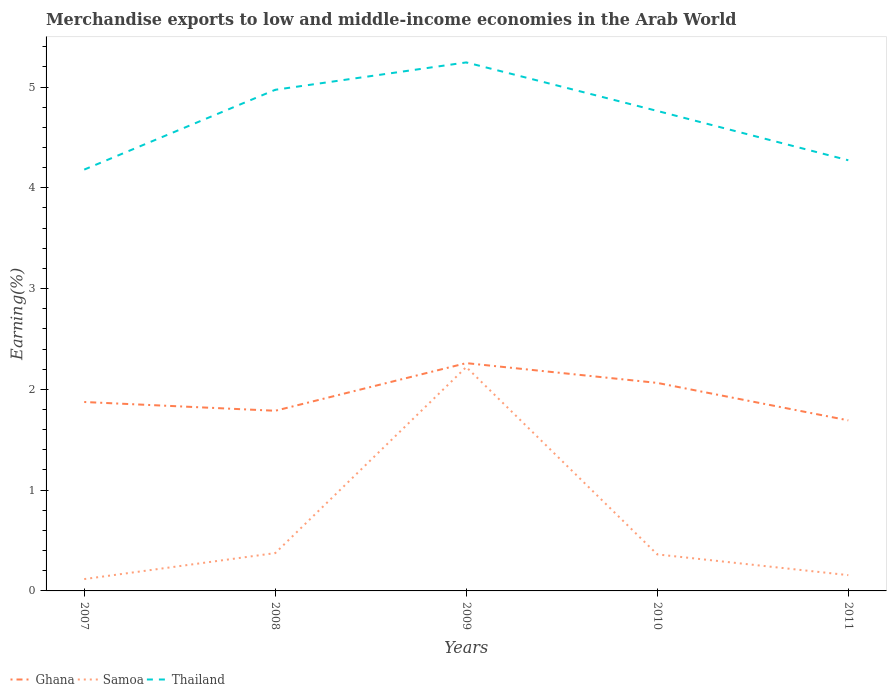Across all years, what is the maximum percentage of amount earned from merchandise exports in Thailand?
Keep it short and to the point. 4.18. What is the total percentage of amount earned from merchandise exports in Samoa in the graph?
Offer a terse response. 0.21. What is the difference between the highest and the second highest percentage of amount earned from merchandise exports in Ghana?
Your response must be concise. 0.57. What is the difference between the highest and the lowest percentage of amount earned from merchandise exports in Ghana?
Your answer should be compact. 2. How many years are there in the graph?
Your response must be concise. 5. What is the difference between two consecutive major ticks on the Y-axis?
Ensure brevity in your answer.  1. Are the values on the major ticks of Y-axis written in scientific E-notation?
Make the answer very short. No. Does the graph contain grids?
Provide a short and direct response. No. How are the legend labels stacked?
Make the answer very short. Horizontal. What is the title of the graph?
Your response must be concise. Merchandise exports to low and middle-income economies in the Arab World. What is the label or title of the Y-axis?
Your answer should be compact. Earning(%). What is the Earning(%) of Ghana in 2007?
Give a very brief answer. 1.87. What is the Earning(%) of Samoa in 2007?
Your answer should be compact. 0.12. What is the Earning(%) in Thailand in 2007?
Keep it short and to the point. 4.18. What is the Earning(%) in Ghana in 2008?
Provide a short and direct response. 1.79. What is the Earning(%) of Samoa in 2008?
Ensure brevity in your answer.  0.38. What is the Earning(%) of Thailand in 2008?
Give a very brief answer. 4.97. What is the Earning(%) in Ghana in 2009?
Your answer should be very brief. 2.26. What is the Earning(%) in Samoa in 2009?
Your answer should be very brief. 2.22. What is the Earning(%) in Thailand in 2009?
Your response must be concise. 5.24. What is the Earning(%) in Ghana in 2010?
Make the answer very short. 2.06. What is the Earning(%) in Samoa in 2010?
Offer a terse response. 0.36. What is the Earning(%) of Thailand in 2010?
Ensure brevity in your answer.  4.76. What is the Earning(%) in Ghana in 2011?
Provide a short and direct response. 1.69. What is the Earning(%) in Samoa in 2011?
Offer a terse response. 0.16. What is the Earning(%) of Thailand in 2011?
Your answer should be very brief. 4.27. Across all years, what is the maximum Earning(%) of Ghana?
Ensure brevity in your answer.  2.26. Across all years, what is the maximum Earning(%) in Samoa?
Offer a very short reply. 2.22. Across all years, what is the maximum Earning(%) of Thailand?
Make the answer very short. 5.24. Across all years, what is the minimum Earning(%) in Ghana?
Provide a short and direct response. 1.69. Across all years, what is the minimum Earning(%) of Samoa?
Ensure brevity in your answer.  0.12. Across all years, what is the minimum Earning(%) in Thailand?
Your response must be concise. 4.18. What is the total Earning(%) of Ghana in the graph?
Your response must be concise. 9.68. What is the total Earning(%) of Samoa in the graph?
Provide a succinct answer. 3.23. What is the total Earning(%) in Thailand in the graph?
Ensure brevity in your answer.  23.43. What is the difference between the Earning(%) of Ghana in 2007 and that in 2008?
Offer a very short reply. 0.09. What is the difference between the Earning(%) of Samoa in 2007 and that in 2008?
Give a very brief answer. -0.26. What is the difference between the Earning(%) of Thailand in 2007 and that in 2008?
Your answer should be compact. -0.79. What is the difference between the Earning(%) of Ghana in 2007 and that in 2009?
Keep it short and to the point. -0.39. What is the difference between the Earning(%) in Samoa in 2007 and that in 2009?
Offer a very short reply. -2.1. What is the difference between the Earning(%) of Thailand in 2007 and that in 2009?
Provide a short and direct response. -1.06. What is the difference between the Earning(%) of Ghana in 2007 and that in 2010?
Ensure brevity in your answer.  -0.19. What is the difference between the Earning(%) in Samoa in 2007 and that in 2010?
Your answer should be compact. -0.24. What is the difference between the Earning(%) of Thailand in 2007 and that in 2010?
Your answer should be very brief. -0.58. What is the difference between the Earning(%) in Ghana in 2007 and that in 2011?
Keep it short and to the point. 0.18. What is the difference between the Earning(%) in Samoa in 2007 and that in 2011?
Give a very brief answer. -0.04. What is the difference between the Earning(%) of Thailand in 2007 and that in 2011?
Offer a terse response. -0.09. What is the difference between the Earning(%) in Ghana in 2008 and that in 2009?
Your answer should be very brief. -0.47. What is the difference between the Earning(%) in Samoa in 2008 and that in 2009?
Provide a short and direct response. -1.85. What is the difference between the Earning(%) in Thailand in 2008 and that in 2009?
Offer a very short reply. -0.27. What is the difference between the Earning(%) of Ghana in 2008 and that in 2010?
Your response must be concise. -0.28. What is the difference between the Earning(%) in Samoa in 2008 and that in 2010?
Offer a terse response. 0.01. What is the difference between the Earning(%) of Thailand in 2008 and that in 2010?
Your response must be concise. 0.21. What is the difference between the Earning(%) of Ghana in 2008 and that in 2011?
Give a very brief answer. 0.1. What is the difference between the Earning(%) of Samoa in 2008 and that in 2011?
Your response must be concise. 0.22. What is the difference between the Earning(%) of Thailand in 2008 and that in 2011?
Offer a very short reply. 0.7. What is the difference between the Earning(%) in Ghana in 2009 and that in 2010?
Ensure brevity in your answer.  0.2. What is the difference between the Earning(%) of Samoa in 2009 and that in 2010?
Give a very brief answer. 1.86. What is the difference between the Earning(%) of Thailand in 2009 and that in 2010?
Offer a very short reply. 0.48. What is the difference between the Earning(%) of Ghana in 2009 and that in 2011?
Give a very brief answer. 0.57. What is the difference between the Earning(%) of Samoa in 2009 and that in 2011?
Your answer should be compact. 2.06. What is the difference between the Earning(%) of Ghana in 2010 and that in 2011?
Make the answer very short. 0.37. What is the difference between the Earning(%) of Samoa in 2010 and that in 2011?
Keep it short and to the point. 0.21. What is the difference between the Earning(%) in Thailand in 2010 and that in 2011?
Offer a terse response. 0.49. What is the difference between the Earning(%) of Ghana in 2007 and the Earning(%) of Samoa in 2008?
Offer a very short reply. 1.5. What is the difference between the Earning(%) of Ghana in 2007 and the Earning(%) of Thailand in 2008?
Your answer should be very brief. -3.1. What is the difference between the Earning(%) in Samoa in 2007 and the Earning(%) in Thailand in 2008?
Make the answer very short. -4.86. What is the difference between the Earning(%) in Ghana in 2007 and the Earning(%) in Samoa in 2009?
Offer a terse response. -0.35. What is the difference between the Earning(%) of Ghana in 2007 and the Earning(%) of Thailand in 2009?
Offer a terse response. -3.37. What is the difference between the Earning(%) of Samoa in 2007 and the Earning(%) of Thailand in 2009?
Offer a terse response. -5.13. What is the difference between the Earning(%) in Ghana in 2007 and the Earning(%) in Samoa in 2010?
Your response must be concise. 1.51. What is the difference between the Earning(%) in Ghana in 2007 and the Earning(%) in Thailand in 2010?
Your response must be concise. -2.89. What is the difference between the Earning(%) of Samoa in 2007 and the Earning(%) of Thailand in 2010?
Your answer should be compact. -4.65. What is the difference between the Earning(%) in Ghana in 2007 and the Earning(%) in Samoa in 2011?
Provide a short and direct response. 1.72. What is the difference between the Earning(%) in Ghana in 2007 and the Earning(%) in Thailand in 2011?
Ensure brevity in your answer.  -2.4. What is the difference between the Earning(%) in Samoa in 2007 and the Earning(%) in Thailand in 2011?
Keep it short and to the point. -4.16. What is the difference between the Earning(%) of Ghana in 2008 and the Earning(%) of Samoa in 2009?
Provide a short and direct response. -0.43. What is the difference between the Earning(%) of Ghana in 2008 and the Earning(%) of Thailand in 2009?
Your response must be concise. -3.46. What is the difference between the Earning(%) of Samoa in 2008 and the Earning(%) of Thailand in 2009?
Ensure brevity in your answer.  -4.87. What is the difference between the Earning(%) of Ghana in 2008 and the Earning(%) of Samoa in 2010?
Give a very brief answer. 1.43. What is the difference between the Earning(%) in Ghana in 2008 and the Earning(%) in Thailand in 2010?
Offer a terse response. -2.98. What is the difference between the Earning(%) in Samoa in 2008 and the Earning(%) in Thailand in 2010?
Ensure brevity in your answer.  -4.39. What is the difference between the Earning(%) of Ghana in 2008 and the Earning(%) of Samoa in 2011?
Offer a very short reply. 1.63. What is the difference between the Earning(%) of Ghana in 2008 and the Earning(%) of Thailand in 2011?
Keep it short and to the point. -2.49. What is the difference between the Earning(%) of Samoa in 2008 and the Earning(%) of Thailand in 2011?
Provide a short and direct response. -3.9. What is the difference between the Earning(%) in Ghana in 2009 and the Earning(%) in Samoa in 2010?
Ensure brevity in your answer.  1.9. What is the difference between the Earning(%) in Ghana in 2009 and the Earning(%) in Thailand in 2010?
Your answer should be very brief. -2.5. What is the difference between the Earning(%) in Samoa in 2009 and the Earning(%) in Thailand in 2010?
Offer a very short reply. -2.54. What is the difference between the Earning(%) of Ghana in 2009 and the Earning(%) of Samoa in 2011?
Offer a very short reply. 2.1. What is the difference between the Earning(%) in Ghana in 2009 and the Earning(%) in Thailand in 2011?
Your answer should be very brief. -2.01. What is the difference between the Earning(%) in Samoa in 2009 and the Earning(%) in Thailand in 2011?
Offer a very short reply. -2.05. What is the difference between the Earning(%) in Ghana in 2010 and the Earning(%) in Samoa in 2011?
Your answer should be very brief. 1.91. What is the difference between the Earning(%) in Ghana in 2010 and the Earning(%) in Thailand in 2011?
Your answer should be compact. -2.21. What is the difference between the Earning(%) of Samoa in 2010 and the Earning(%) of Thailand in 2011?
Offer a very short reply. -3.91. What is the average Earning(%) of Ghana per year?
Your response must be concise. 1.94. What is the average Earning(%) in Samoa per year?
Offer a very short reply. 0.65. What is the average Earning(%) of Thailand per year?
Give a very brief answer. 4.69. In the year 2007, what is the difference between the Earning(%) in Ghana and Earning(%) in Samoa?
Make the answer very short. 1.76. In the year 2007, what is the difference between the Earning(%) of Ghana and Earning(%) of Thailand?
Your answer should be compact. -2.31. In the year 2007, what is the difference between the Earning(%) in Samoa and Earning(%) in Thailand?
Offer a terse response. -4.06. In the year 2008, what is the difference between the Earning(%) of Ghana and Earning(%) of Samoa?
Your answer should be compact. 1.41. In the year 2008, what is the difference between the Earning(%) in Ghana and Earning(%) in Thailand?
Offer a terse response. -3.19. In the year 2008, what is the difference between the Earning(%) of Samoa and Earning(%) of Thailand?
Offer a very short reply. -4.6. In the year 2009, what is the difference between the Earning(%) of Ghana and Earning(%) of Samoa?
Keep it short and to the point. 0.04. In the year 2009, what is the difference between the Earning(%) of Ghana and Earning(%) of Thailand?
Your answer should be very brief. -2.98. In the year 2009, what is the difference between the Earning(%) of Samoa and Earning(%) of Thailand?
Your answer should be very brief. -3.02. In the year 2010, what is the difference between the Earning(%) of Ghana and Earning(%) of Samoa?
Give a very brief answer. 1.7. In the year 2010, what is the difference between the Earning(%) in Ghana and Earning(%) in Thailand?
Provide a short and direct response. -2.7. In the year 2010, what is the difference between the Earning(%) in Samoa and Earning(%) in Thailand?
Your answer should be very brief. -4.4. In the year 2011, what is the difference between the Earning(%) in Ghana and Earning(%) in Samoa?
Make the answer very short. 1.54. In the year 2011, what is the difference between the Earning(%) in Ghana and Earning(%) in Thailand?
Provide a short and direct response. -2.58. In the year 2011, what is the difference between the Earning(%) in Samoa and Earning(%) in Thailand?
Provide a short and direct response. -4.12. What is the ratio of the Earning(%) of Ghana in 2007 to that in 2008?
Keep it short and to the point. 1.05. What is the ratio of the Earning(%) of Samoa in 2007 to that in 2008?
Ensure brevity in your answer.  0.31. What is the ratio of the Earning(%) of Thailand in 2007 to that in 2008?
Ensure brevity in your answer.  0.84. What is the ratio of the Earning(%) in Ghana in 2007 to that in 2009?
Your answer should be compact. 0.83. What is the ratio of the Earning(%) in Samoa in 2007 to that in 2009?
Keep it short and to the point. 0.05. What is the ratio of the Earning(%) of Thailand in 2007 to that in 2009?
Your answer should be very brief. 0.8. What is the ratio of the Earning(%) in Ghana in 2007 to that in 2010?
Keep it short and to the point. 0.91. What is the ratio of the Earning(%) in Samoa in 2007 to that in 2010?
Your answer should be compact. 0.32. What is the ratio of the Earning(%) of Thailand in 2007 to that in 2010?
Keep it short and to the point. 0.88. What is the ratio of the Earning(%) in Ghana in 2007 to that in 2011?
Your response must be concise. 1.11. What is the ratio of the Earning(%) in Samoa in 2007 to that in 2011?
Your answer should be compact. 0.75. What is the ratio of the Earning(%) of Thailand in 2007 to that in 2011?
Offer a terse response. 0.98. What is the ratio of the Earning(%) of Ghana in 2008 to that in 2009?
Offer a very short reply. 0.79. What is the ratio of the Earning(%) of Samoa in 2008 to that in 2009?
Ensure brevity in your answer.  0.17. What is the ratio of the Earning(%) in Thailand in 2008 to that in 2009?
Provide a short and direct response. 0.95. What is the ratio of the Earning(%) of Ghana in 2008 to that in 2010?
Your response must be concise. 0.87. What is the ratio of the Earning(%) in Samoa in 2008 to that in 2010?
Your response must be concise. 1.04. What is the ratio of the Earning(%) of Thailand in 2008 to that in 2010?
Provide a short and direct response. 1.04. What is the ratio of the Earning(%) of Ghana in 2008 to that in 2011?
Provide a succinct answer. 1.06. What is the ratio of the Earning(%) in Samoa in 2008 to that in 2011?
Give a very brief answer. 2.4. What is the ratio of the Earning(%) in Thailand in 2008 to that in 2011?
Your response must be concise. 1.16. What is the ratio of the Earning(%) of Ghana in 2009 to that in 2010?
Give a very brief answer. 1.1. What is the ratio of the Earning(%) of Samoa in 2009 to that in 2010?
Offer a terse response. 6.13. What is the ratio of the Earning(%) in Thailand in 2009 to that in 2010?
Your answer should be compact. 1.1. What is the ratio of the Earning(%) in Ghana in 2009 to that in 2011?
Offer a terse response. 1.34. What is the ratio of the Earning(%) of Samoa in 2009 to that in 2011?
Offer a very short reply. 14.18. What is the ratio of the Earning(%) of Thailand in 2009 to that in 2011?
Give a very brief answer. 1.23. What is the ratio of the Earning(%) of Ghana in 2010 to that in 2011?
Offer a very short reply. 1.22. What is the ratio of the Earning(%) in Samoa in 2010 to that in 2011?
Offer a very short reply. 2.31. What is the ratio of the Earning(%) in Thailand in 2010 to that in 2011?
Ensure brevity in your answer.  1.11. What is the difference between the highest and the second highest Earning(%) in Ghana?
Provide a succinct answer. 0.2. What is the difference between the highest and the second highest Earning(%) of Samoa?
Give a very brief answer. 1.85. What is the difference between the highest and the second highest Earning(%) in Thailand?
Keep it short and to the point. 0.27. What is the difference between the highest and the lowest Earning(%) of Ghana?
Your response must be concise. 0.57. What is the difference between the highest and the lowest Earning(%) of Samoa?
Provide a succinct answer. 2.1. What is the difference between the highest and the lowest Earning(%) in Thailand?
Ensure brevity in your answer.  1.06. 